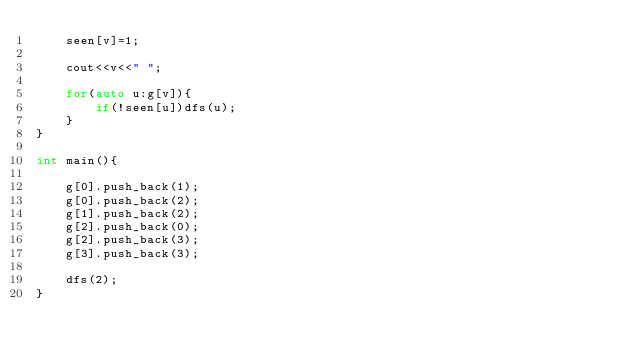Convert code to text. <code><loc_0><loc_0><loc_500><loc_500><_C++_>    seen[v]=1;

    cout<<v<<" ";

    for(auto u:g[v]){
        if(!seen[u])dfs(u);
    }
}

int main(){

    g[0].push_back(1);
    g[0].push_back(2);
    g[1].push_back(2);
    g[2].push_back(0);
    g[2].push_back(3);
    g[3].push_back(3);

    dfs(2);
}
</code> 